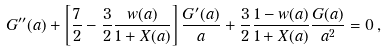Convert formula to latex. <formula><loc_0><loc_0><loc_500><loc_500>G ^ { \prime \prime } ( a ) + \left [ \frac { 7 } { 2 } - \frac { 3 } { 2 } \frac { w ( a ) } { 1 + X ( a ) } \right ] \frac { G ^ { \prime } ( a ) } { a } + \frac { 3 } { 2 } \frac { 1 - w ( a ) } { 1 + X ( a ) } \frac { G ( a ) } { a ^ { 2 } } = 0 \, ,</formula> 